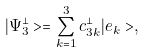<formula> <loc_0><loc_0><loc_500><loc_500>| \Psi ^ { \bot } _ { 3 } > = \sum _ { k = 1 } ^ { 3 } c _ { 3 k } ^ { \bot } | e _ { k } > ,</formula> 